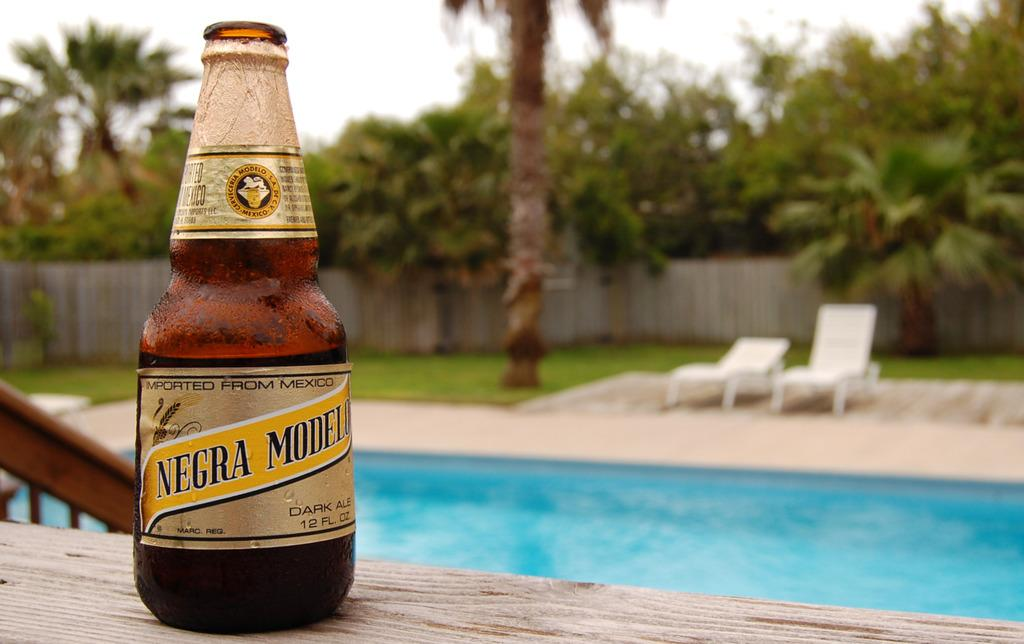<image>
Share a concise interpretation of the image provided. A bottle of Negra Modelo with a pool in the background. 